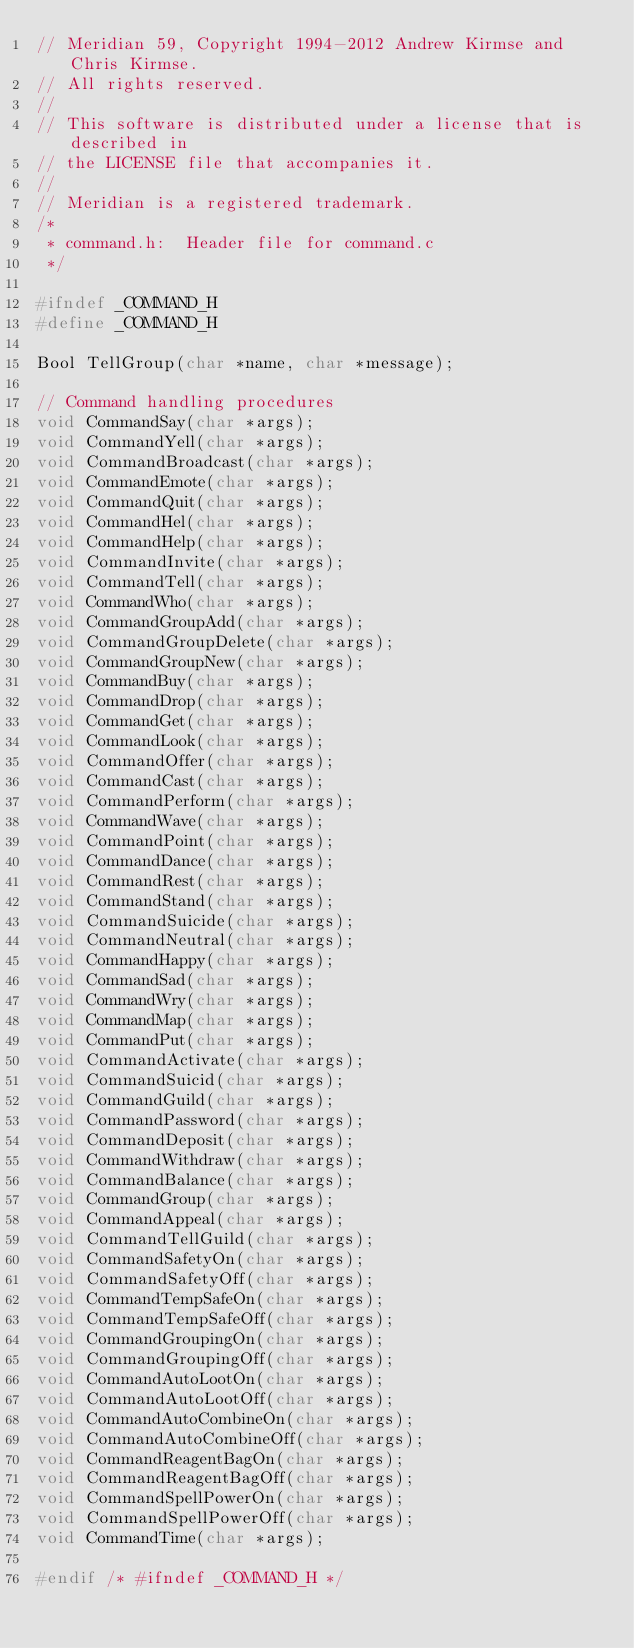<code> <loc_0><loc_0><loc_500><loc_500><_C_>// Meridian 59, Copyright 1994-2012 Andrew Kirmse and Chris Kirmse.
// All rights reserved.
//
// This software is distributed under a license that is described in
// the LICENSE file that accompanies it.
//
// Meridian is a registered trademark.
/*
 * command.h:  Header file for command.c
 */

#ifndef _COMMAND_H
#define _COMMAND_H

Bool TellGroup(char *name, char *message);

// Command handling procedures
void CommandSay(char *args);
void CommandYell(char *args);
void CommandBroadcast(char *args);
void CommandEmote(char *args);
void CommandQuit(char *args);
void CommandHel(char *args);
void CommandHelp(char *args);
void CommandInvite(char *args);
void CommandTell(char *args);
void CommandWho(char *args);
void CommandGroupAdd(char *args);
void CommandGroupDelete(char *args);
void CommandGroupNew(char *args);
void CommandBuy(char *args);
void CommandDrop(char *args);
void CommandGet(char *args);
void CommandLook(char *args);
void CommandOffer(char *args);
void CommandCast(char *args);
void CommandPerform(char *args);
void CommandWave(char *args);
void CommandPoint(char *args);
void CommandDance(char *args);
void CommandRest(char *args);
void CommandStand(char *args);
void CommandSuicide(char *args);
void CommandNeutral(char *args);
void CommandHappy(char *args);
void CommandSad(char *args);
void CommandWry(char *args);
void CommandMap(char *args);
void CommandPut(char *args);
void CommandActivate(char *args);
void CommandSuicid(char *args);
void CommandGuild(char *args);
void CommandPassword(char *args);
void CommandDeposit(char *args);
void CommandWithdraw(char *args);
void CommandBalance(char *args);
void CommandGroup(char *args);
void CommandAppeal(char *args);
void CommandTellGuild(char *args);
void CommandSafetyOn(char *args);
void CommandSafetyOff(char *args);
void CommandTempSafeOn(char *args);
void CommandTempSafeOff(char *args);
void CommandGroupingOn(char *args);
void CommandGroupingOff(char *args);
void CommandAutoLootOn(char *args);
void CommandAutoLootOff(char *args);
void CommandAutoCombineOn(char *args);
void CommandAutoCombineOff(char *args);
void CommandReagentBagOn(char *args);
void CommandReagentBagOff(char *args);
void CommandSpellPowerOn(char *args);
void CommandSpellPowerOff(char *args);
void CommandTime(char *args);

#endif /* #ifndef _COMMAND_H */
</code> 